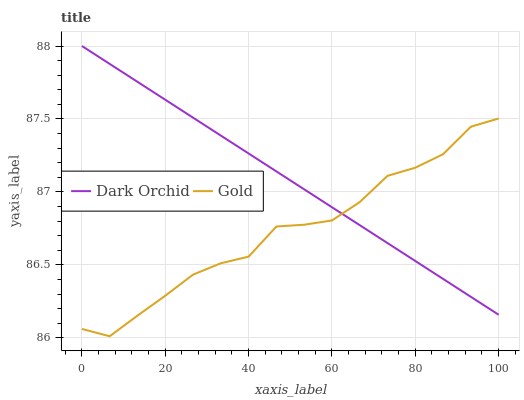Does Gold have the minimum area under the curve?
Answer yes or no. Yes. Does Dark Orchid have the maximum area under the curve?
Answer yes or no. Yes. Does Dark Orchid have the minimum area under the curve?
Answer yes or no. No. Is Dark Orchid the smoothest?
Answer yes or no. Yes. Is Gold the roughest?
Answer yes or no. Yes. Is Dark Orchid the roughest?
Answer yes or no. No. Does Gold have the lowest value?
Answer yes or no. Yes. Does Dark Orchid have the lowest value?
Answer yes or no. No. Does Dark Orchid have the highest value?
Answer yes or no. Yes. Does Gold intersect Dark Orchid?
Answer yes or no. Yes. Is Gold less than Dark Orchid?
Answer yes or no. No. Is Gold greater than Dark Orchid?
Answer yes or no. No. 